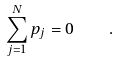<formula> <loc_0><loc_0><loc_500><loc_500>\sum _ { j = 1 } ^ { N } p _ { j } = 0 \quad .</formula> 